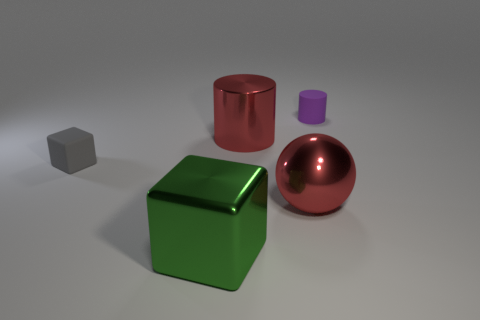Do the big cylinder and the large sphere have the same color?
Offer a very short reply. Yes. What size is the red ball?
Ensure brevity in your answer.  Large. What number of large cylinders are the same color as the ball?
Offer a terse response. 1. There is a large thing that is in front of the big red thing that is in front of the shiny cylinder; is there a large red metal cylinder that is left of it?
Your answer should be very brief. No. The gray matte thing that is the same size as the purple matte cylinder is what shape?
Provide a succinct answer. Cube. How many large things are either purple things or blue matte cylinders?
Keep it short and to the point. 0. The cylinder that is the same material as the small gray cube is what color?
Your response must be concise. Purple. There is a large red metal object that is behind the small matte block; is it the same shape as the big red shiny thing that is in front of the matte cube?
Give a very brief answer. No. How many rubber objects are balls or purple objects?
Offer a very short reply. 1. There is a large ball that is the same color as the large metallic cylinder; what is it made of?
Provide a succinct answer. Metal. 